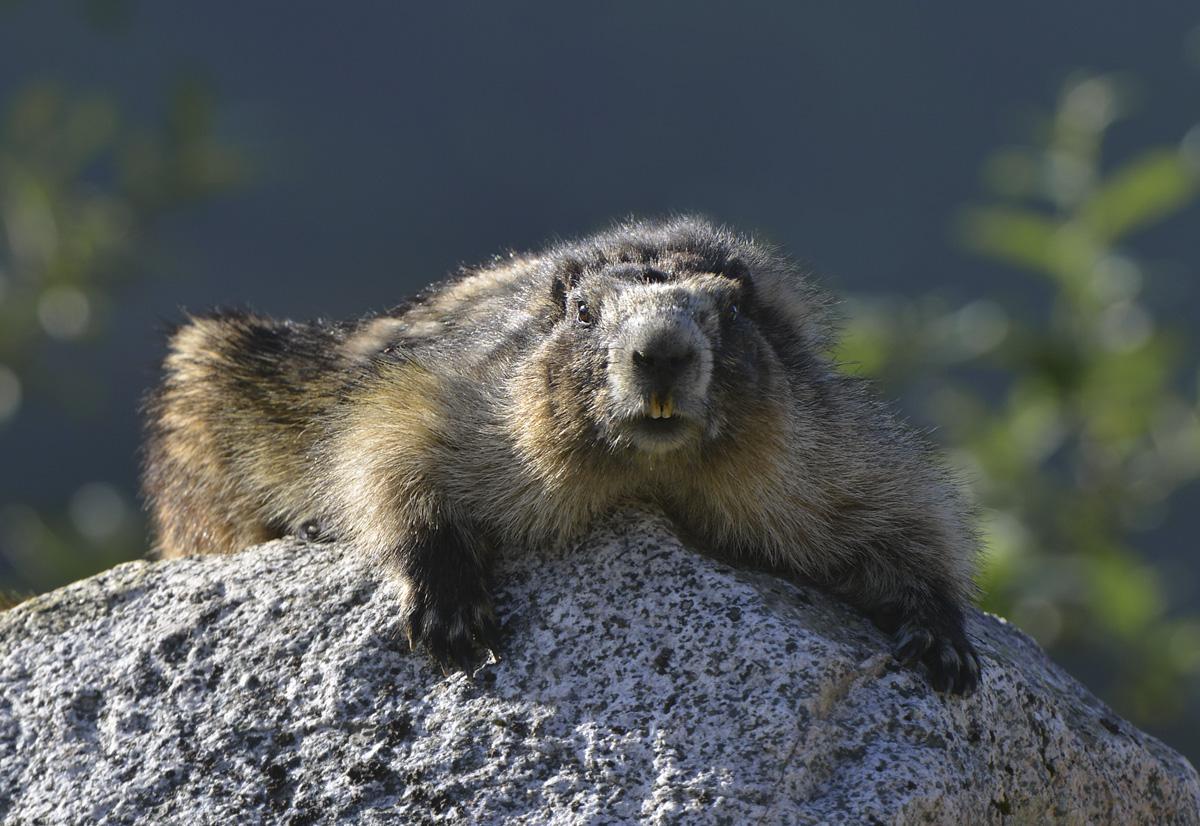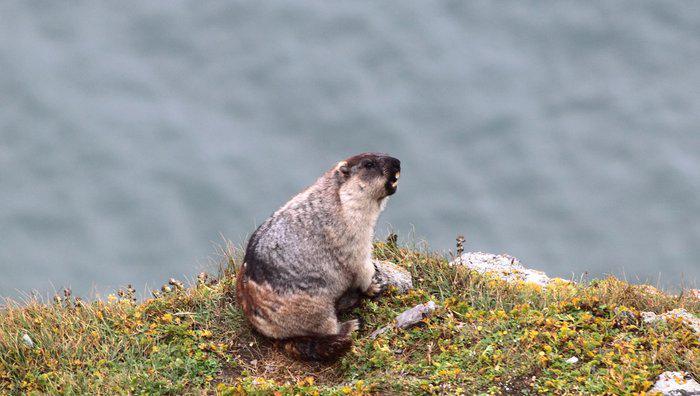The first image is the image on the left, the second image is the image on the right. For the images shown, is this caption "The marmot in the left image is looking in the direction of the camera" true? Answer yes or no. Yes. The first image is the image on the left, the second image is the image on the right. For the images displayed, is the sentence "The animals in the image on the left are on a rocky peak." factually correct? Answer yes or no. Yes. 